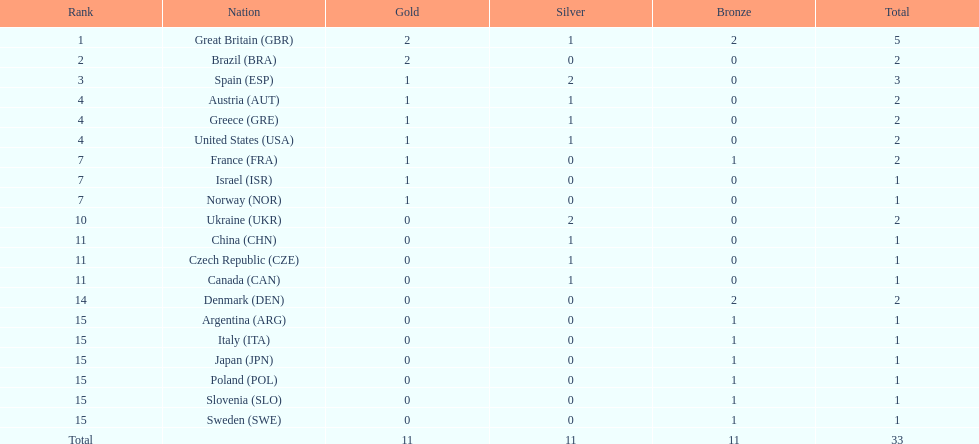Who won more gold medals than spain? Great Britain (GBR), Brazil (BRA). 